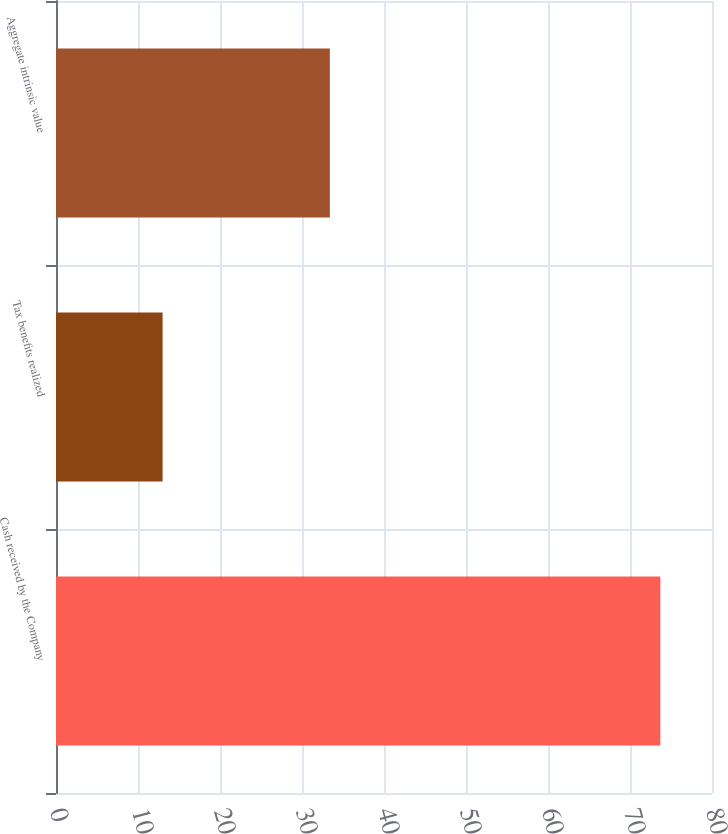Convert chart. <chart><loc_0><loc_0><loc_500><loc_500><bar_chart><fcel>Cash received by the Company<fcel>Tax benefits realized<fcel>Aggregate intrinsic value<nl><fcel>73.7<fcel>13<fcel>33.4<nl></chart> 